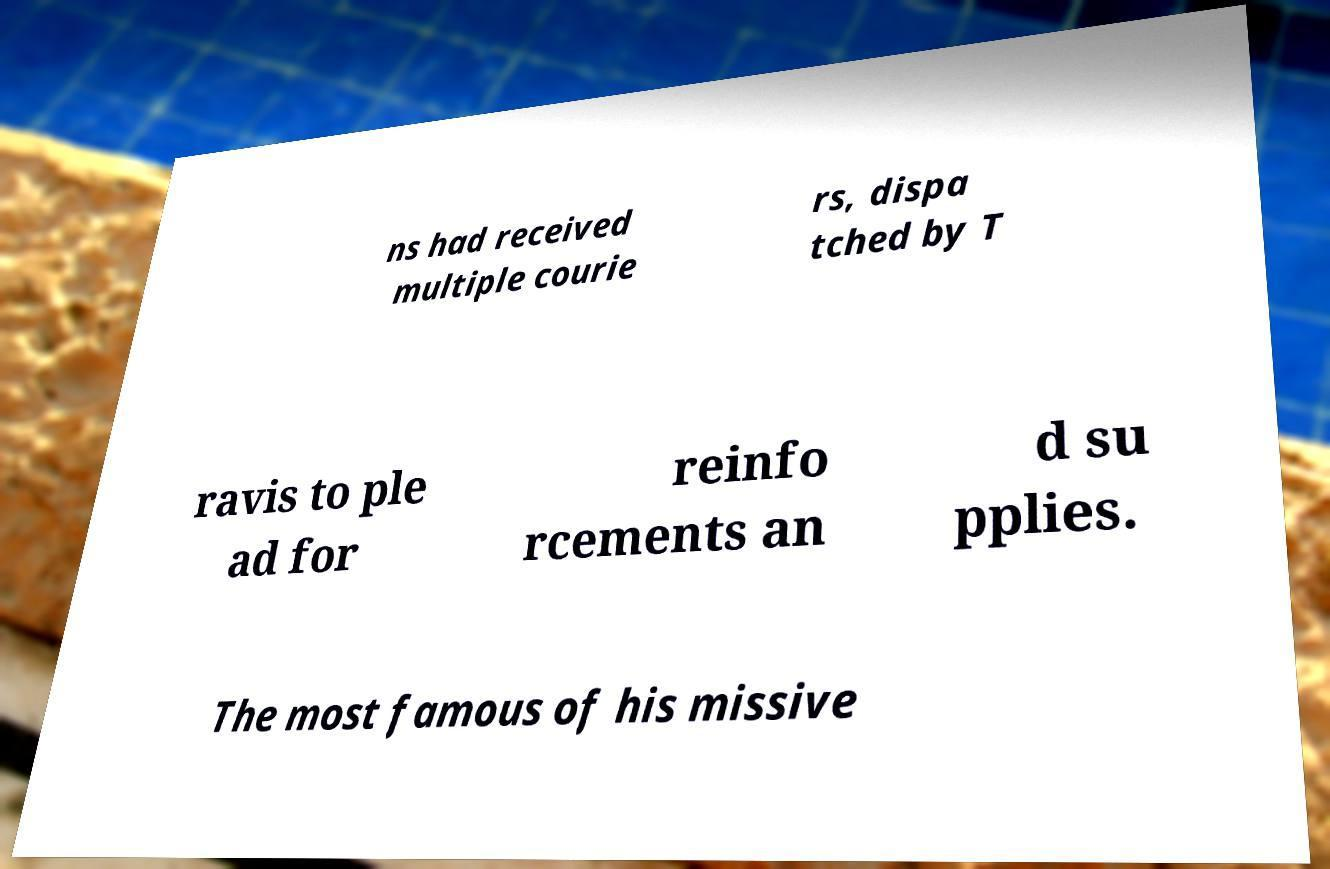What messages or text are displayed in this image? I need them in a readable, typed format. ns had received multiple courie rs, dispa tched by T ravis to ple ad for reinfo rcements an d su pplies. The most famous of his missive 